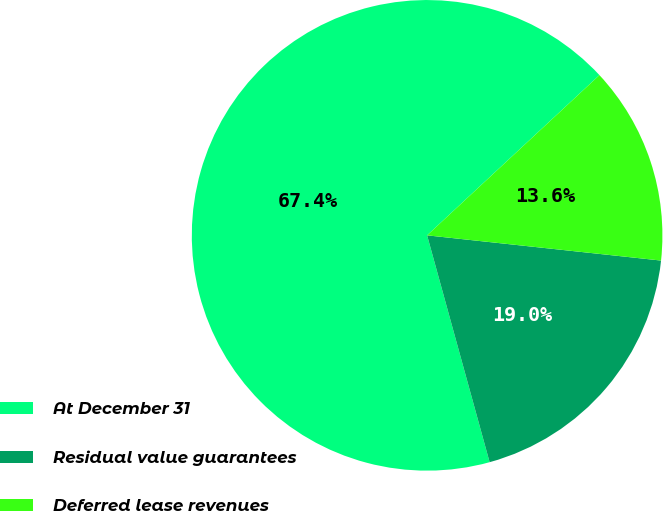<chart> <loc_0><loc_0><loc_500><loc_500><pie_chart><fcel>At December 31<fcel>Residual value guarantees<fcel>Deferred lease revenues<nl><fcel>67.36%<fcel>19.01%<fcel>13.63%<nl></chart> 